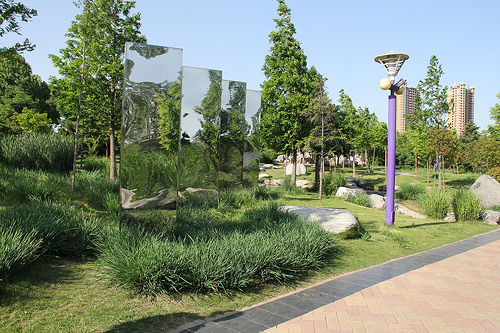<image>
Is there a grass to the right of the road? Yes. From this viewpoint, the grass is positioned to the right side relative to the road. 